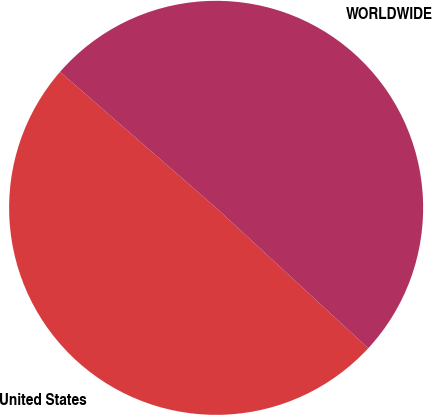<chart> <loc_0><loc_0><loc_500><loc_500><pie_chart><fcel>United States<fcel>WORLDWIDE<nl><fcel>49.54%<fcel>50.46%<nl></chart> 